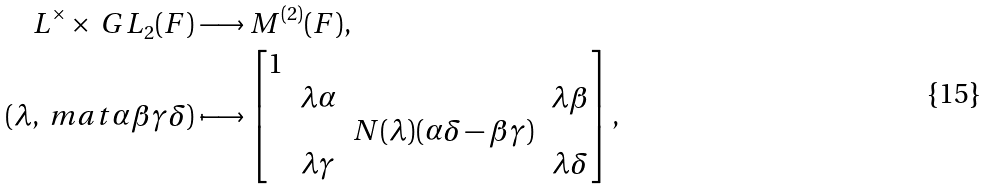<formula> <loc_0><loc_0><loc_500><loc_500>L ^ { \times } \times \ G L _ { 2 } ( F ) & \longrightarrow M ^ { ( 2 ) } ( F ) , \\ ( \lambda , \ m a t { \alpha } { \beta } { \gamma } { \delta } ) & \longmapsto \begin{bmatrix} 1 \\ & \lambda \alpha & & \lambda \beta \\ & & N ( \lambda ) ( \alpha \delta - \beta \gamma ) \\ & \lambda \gamma & & \lambda \delta \end{bmatrix} ,</formula> 